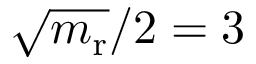Convert formula to latex. <formula><loc_0><loc_0><loc_500><loc_500>\sqrt { m _ { r } } / 2 = 3</formula> 